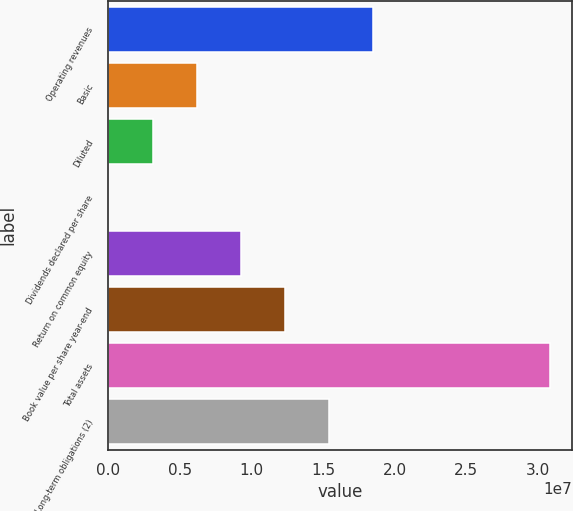Convert chart. <chart><loc_0><loc_0><loc_500><loc_500><bar_chart><fcel>Operating revenues<fcel>Basic<fcel>Diluted<fcel>Dividends declared per share<fcel>Return on common equity<fcel>Book value per share year-end<fcel>Total assets<fcel>Long-term obligations (2)<nl><fcel>1.85146e+07<fcel>6.17153e+06<fcel>3.08577e+06<fcel>2.16<fcel>9.2573e+06<fcel>1.23431e+07<fcel>3.08577e+07<fcel>1.54288e+07<nl></chart> 